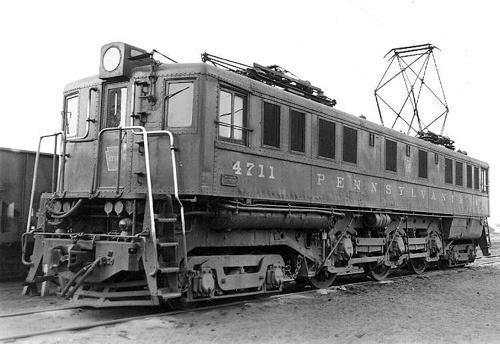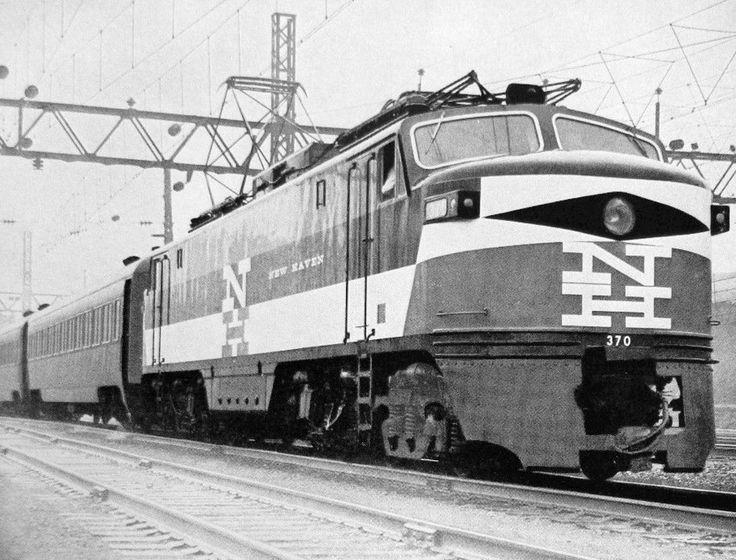The first image is the image on the left, the second image is the image on the right. Examine the images to the left and right. Is the description "The trains in the left and right images head away from each other, in opposite directions." accurate? Answer yes or no. Yes. The first image is the image on the left, the second image is the image on the right. Evaluate the accuracy of this statement regarding the images: "There are two trains in total traveling in opposite direction.". Is it true? Answer yes or no. Yes. 